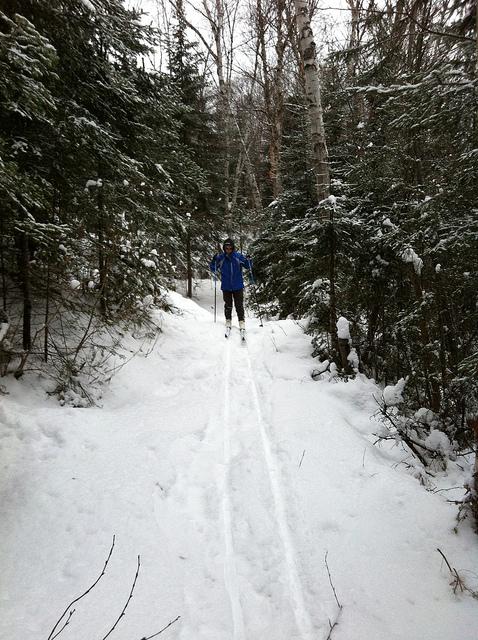Are the trees bare?
Give a very brief answer. No. What is the man doing in blue?
Concise answer only. Skiing. Have other people been in the snow?
Keep it brief. Yes. How many tracks can be seen in the snow?
Keep it brief. 2. What kind of skiing is this?
Give a very brief answer. Cross country. Is the snow deep?
Short answer required. Yes. How many poles can be seen?
Concise answer only. 2. 